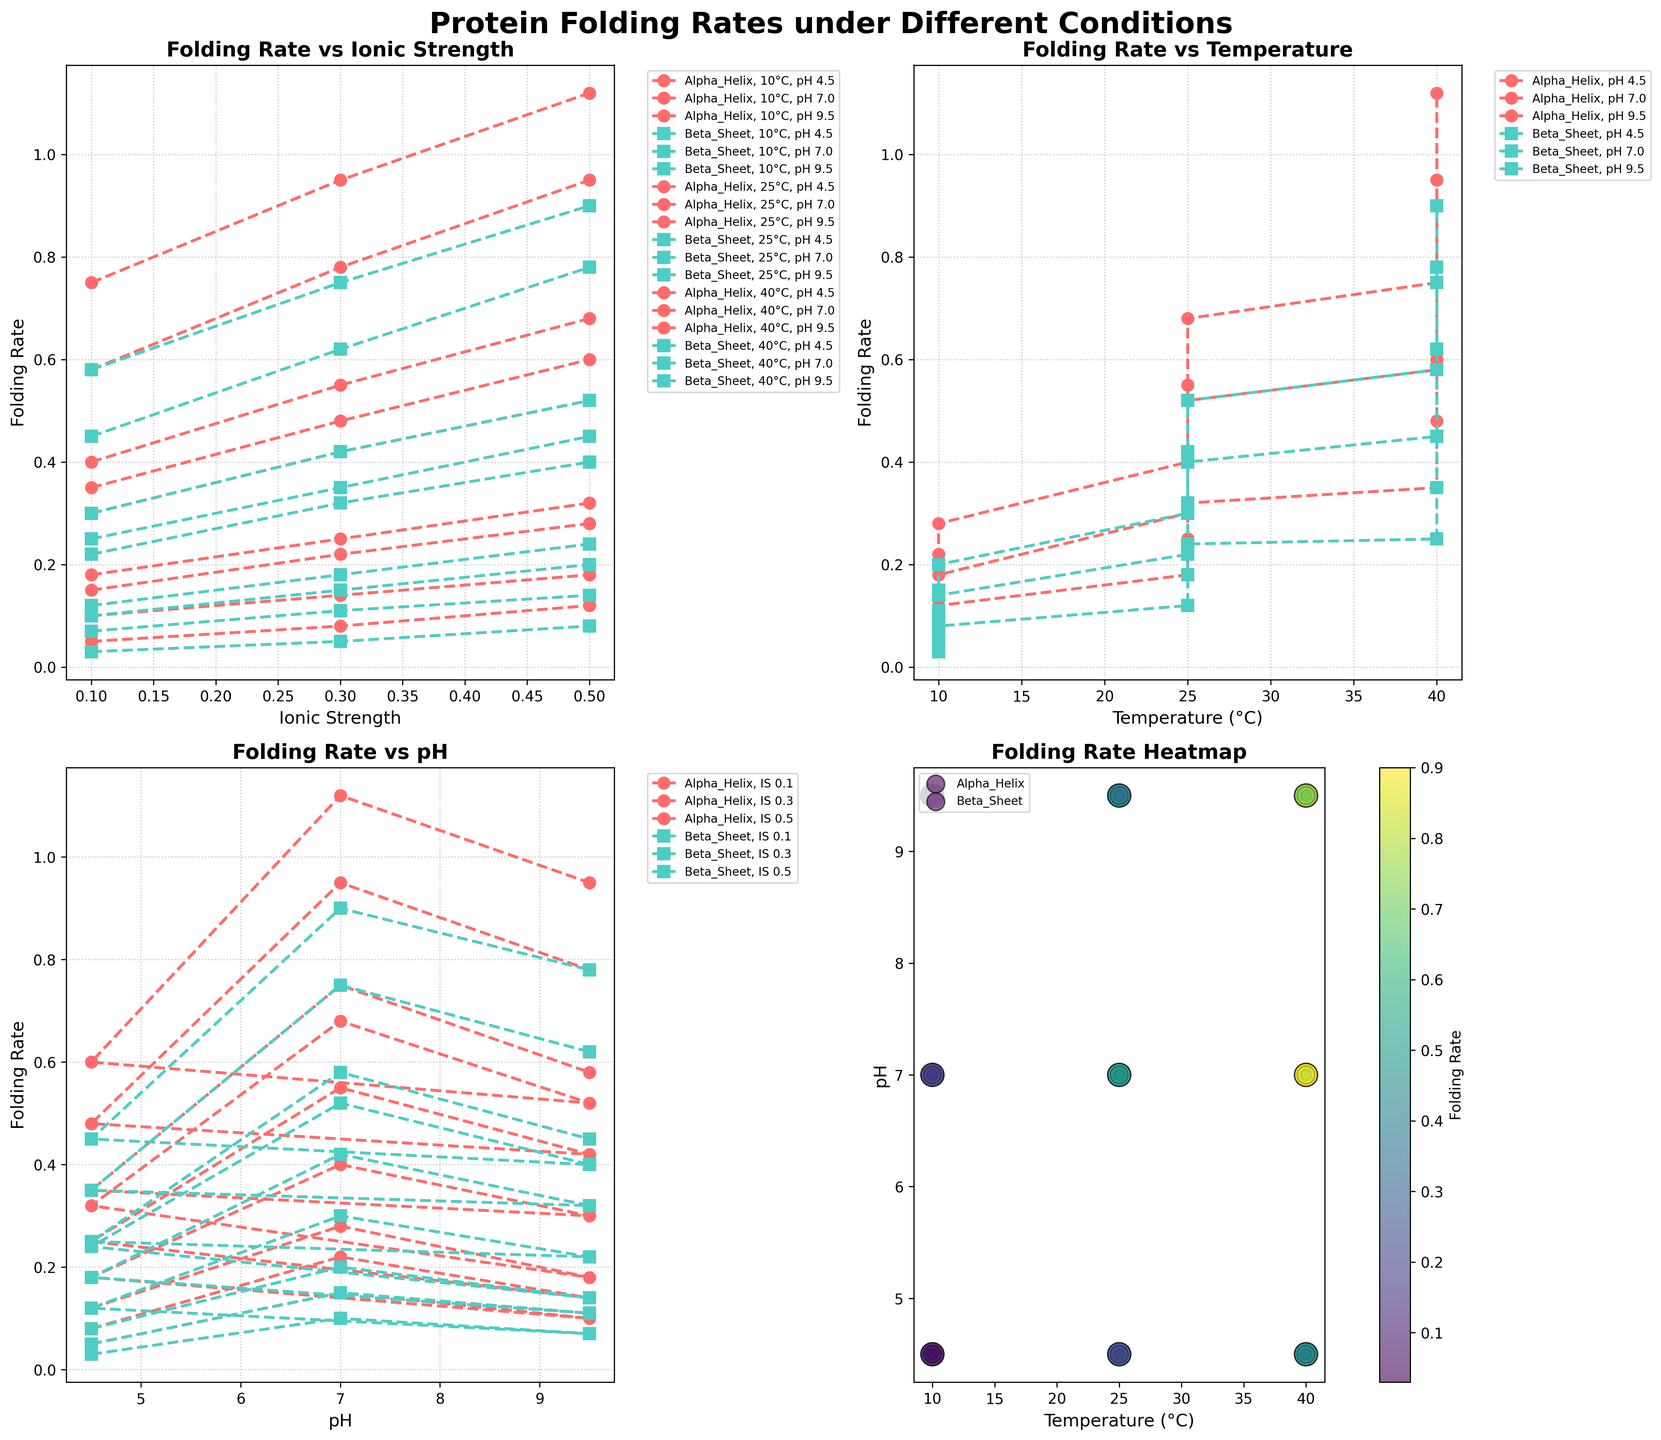What is the folding rate of Alpha Helix at 25°C, pH 7.0, and ionic strength of 0.3 based on the Folding Rate vs Ionic Strength subplot? Look at the subplot Folding Rate vs Ionic Strength. Find the line marked with "Alpha_Helix, 25°C, pH 7.0" and find the point where the ionic strength is 0.3. The corresponding folding rate is approximately 0.55.
Answer: 0.55 Which protein type has a higher folding rate at 40°C, pH 7.0, and ionic strength of 0.1 based on the Folding Rate vs Temperature subplot? Look at the subplot Folding Rate vs Temperature. For pH 7.0, observe the value of the folding rate for both protein types at 40°C. The Alpha Helix has a folding rate of 0.75 and Beta Sheet has a rate of 0.58. Therefore, Alpha Helix has a higher folding rate.
Answer: Alpha Helix Does the folding rate generally increase, decrease, or remain constant with increasing ionic strength at 10°C and pH 4.5 for both protein types based on the Folding Rate vs Ionic Strength subplot? Look at the subplot Folding Rate vs Ionic Strength. Follow the lines for both protein types at 10°C and pH 4.5. For both Alpha Helix and Beta Sheet, the folding rate increases with increasing ionic strength.
Answer: Increase What is the general trend in the folding rate of Alpha Helix as the temperature increases from 10°C to 40°C at pH 7.0? Look at the subplot Folding Rate vs Temperature. Find the line for Alpha Helix at pH 7.0. As the temperature increases from 10°C to 40°C, the folding rate increases.
Answer: Increase How do the folding rates of Beta Sheet and Alpha Helix compare at 40°C, pH 9.5, and ionic strength of 0.5 based on the Folding Rate Heatmap subplot? Look at the heatmap (subplot Folding Rate Heatmap). Compare the colors at the intersection of 40°C, pH 9.5 for both protein types. Additionally, observe the size of the markers. The folding rate for Alpha Helix is given by a larger size and different shading than for Beta Sheet, indicating that Alpha Helix has a higher folding rate.
Answer: Alpha Helix has a higher folding rate In the Folding Rate vs pH subplot, how does the folding rate of Beta Sheet at ionic strength 0.5 change from pH 4.5 to 9.5? Look at the Folding Rate vs pH subplot. Follow the line for Beta Sheet at ionic strength 0.5. Observe the change in the folding rate as pH goes from 4.5 to 9.5. The folding rate increases from approximately 0.08 to 0.78.
Answer: Increase Which protein type exhibits a more significant change in folding rate with increasing temperature at pH 4.5, Alpha Helix or Beta Sheet? Look at the Folding Rate vs Temperature subplot. Focus on the lines for pH 4.5 for both Alpha Helix and Beta Sheet. Measure the change from 10°C to 40°C. Alpha Helix goes from approximately 0.05 to 0.60, while Beta Sheet goes from 0.03 to 0.45. The change is more significant for Alpha Helix.
Answer: Alpha Helix 